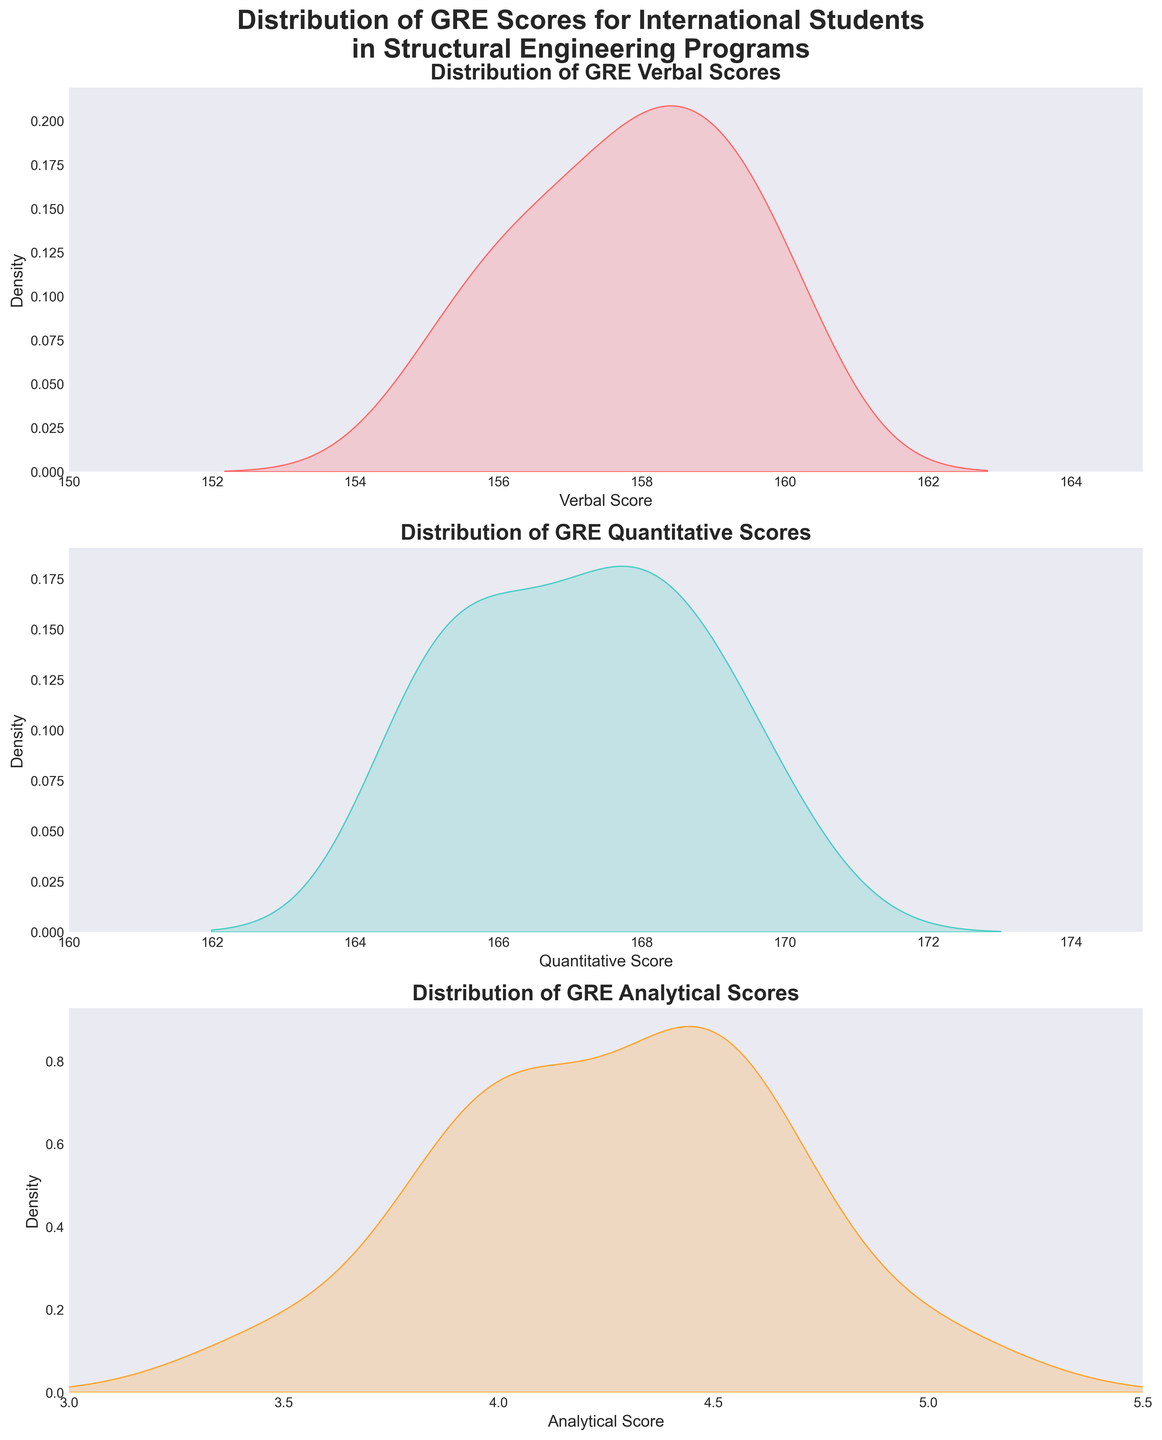What is the range of GRE Verbal scores shown in the distribution? The title of the first subplot is “Distribution of GRE Verbal Scores,” and the x-axis for this plot ranges from 150 to 165.
Answer: 150 to 165 What color is used to shade the GRE Quantitative scores distribution? The color used to shade the GRE Quantitative scores distribution is shown in the second subplot, which is turquoise.
Answer: Turquoise What is the x-axis range for the Analytical scores distribution? The title of the third subplot is “Distribution of GRE Analytical Scores,” and its x-axis ranges from 3 to 5.5.
Answer: 3 to 5.5 Which GRE score type has the highest density peak? By comparing the density peaks of the three subplots, the GRE Quantitative scores have the highest density peak.
Answer: GRE Quantitative How does the density of GRE Analytical scores compare at the score of 4.5 to the score of 3.5? From the third subplot, the density at the score of 4.5 is noticeably higher than at the score of 3.5.
Answer: Higher at 4.5 Which section of the GRE scores has the narrowest distribution range? By looking at the x-axis ranges, GRE Verbal scores have the narrowest distribution range from 150 to 165.
Answer: GRE Verbal What is the most frequent GRE Verbal score range? The peak of the GRE Verbal score density, visible on the first subplot, is around the score range of 158 to 160.
Answer: 158 to 160 Compare the widths of the peaks of the Verbal and Quantitative scores. Which one is wider? Observing the width at the peak density of both plots, the peak of the GRE Quantitative scores is narrower than that of the GRE Verbal scores.
Answer: GRE Verbal How does the distribution of GRE Analytical scores differ from that of GRE Quantitative scores? The GRE Analytical scores distribution, shown in the third subplot, has a broader and flatter shape, while the Quantitative distribution, shown in the second subplot, is narrower and has a higher peak.
Answer: Broader and flatter for Analytical, narrower and higher peak for Quantitative 